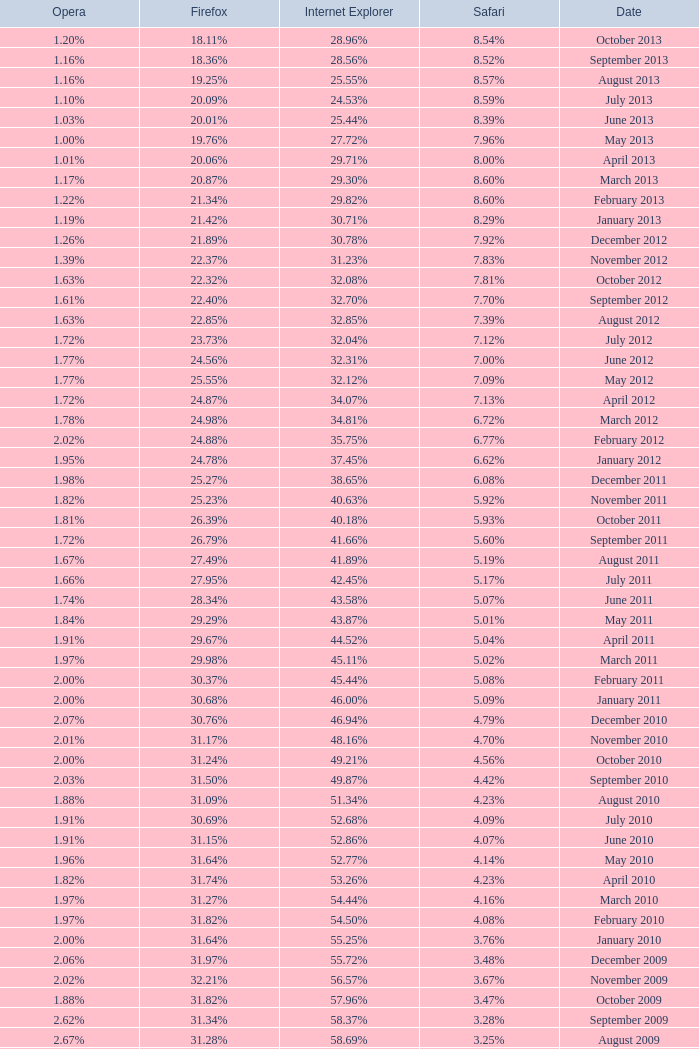What percentage of browsers were using Opera in October 2010? 2.00%. 